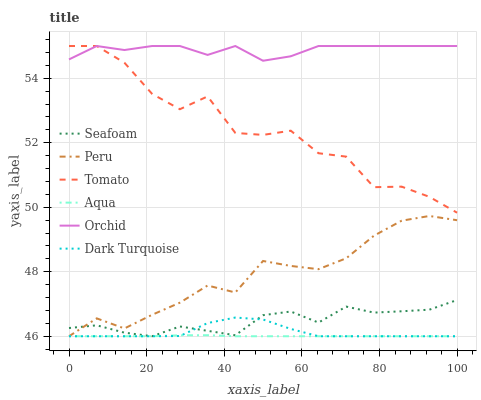Does Aqua have the minimum area under the curve?
Answer yes or no. Yes. Does Orchid have the maximum area under the curve?
Answer yes or no. Yes. Does Dark Turquoise have the minimum area under the curve?
Answer yes or no. No. Does Dark Turquoise have the maximum area under the curve?
Answer yes or no. No. Is Aqua the smoothest?
Answer yes or no. Yes. Is Tomato the roughest?
Answer yes or no. Yes. Is Dark Turquoise the smoothest?
Answer yes or no. No. Is Dark Turquoise the roughest?
Answer yes or no. No. Does Dark Turquoise have the lowest value?
Answer yes or no. Yes. Does Orchid have the lowest value?
Answer yes or no. No. Does Orchid have the highest value?
Answer yes or no. Yes. Does Dark Turquoise have the highest value?
Answer yes or no. No. Is Aqua less than Orchid?
Answer yes or no. Yes. Is Orchid greater than Seafoam?
Answer yes or no. Yes. Does Seafoam intersect Aqua?
Answer yes or no. Yes. Is Seafoam less than Aqua?
Answer yes or no. No. Is Seafoam greater than Aqua?
Answer yes or no. No. Does Aqua intersect Orchid?
Answer yes or no. No. 